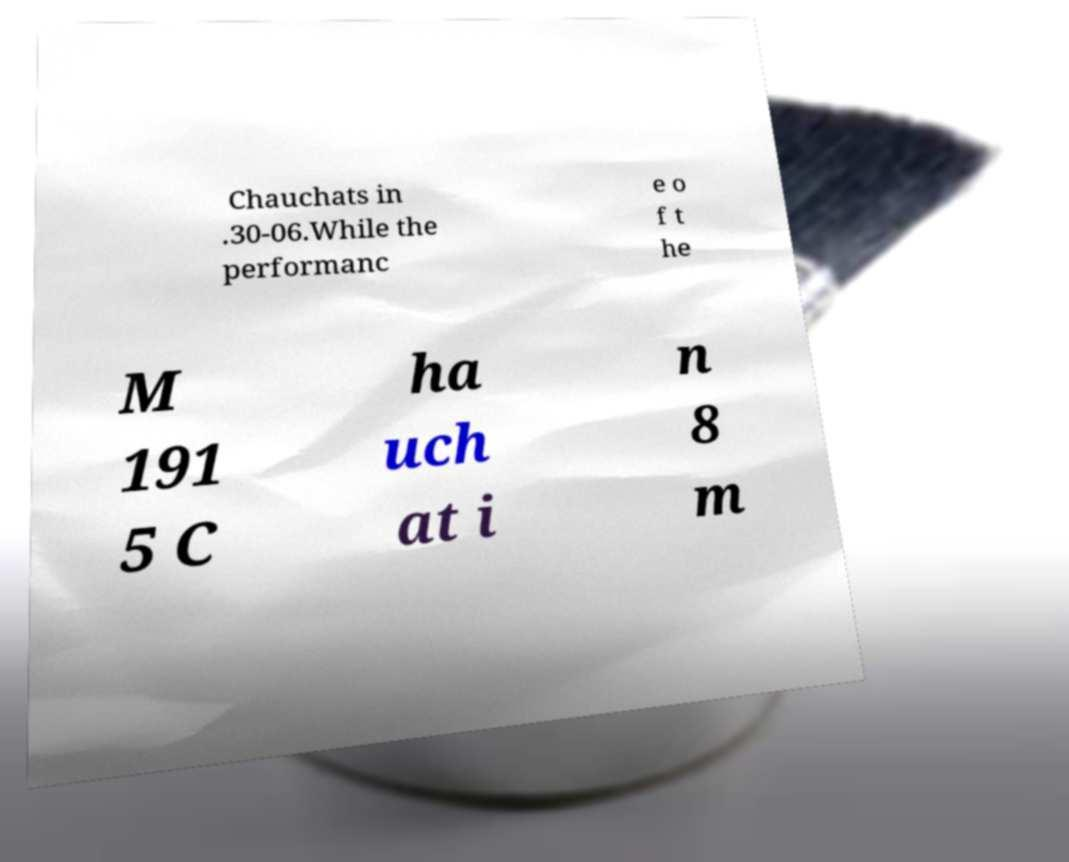Could you extract and type out the text from this image? Chauchats in .30-06.While the performanc e o f t he M 191 5 C ha uch at i n 8 m 